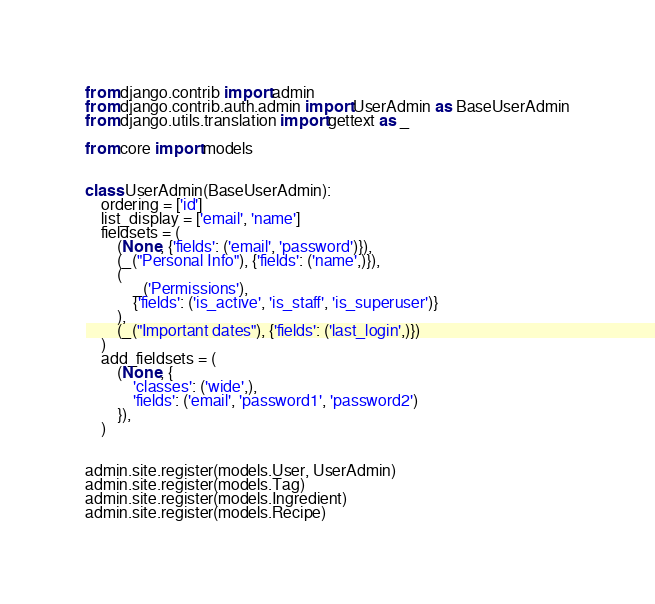Convert code to text. <code><loc_0><loc_0><loc_500><loc_500><_Python_>from django.contrib import admin
from django.contrib.auth.admin import UserAdmin as BaseUserAdmin
from django.utils.translation import gettext as _

from core import models


class UserAdmin(BaseUserAdmin):
    ordering = ['id']
    list_display = ['email', 'name']
    fieldsets = (
        (None, {'fields': ('email', 'password')}),
        (_("Personal Info"), {'fields': ('name',)}),
        (
            _('Permissions'),
            {'fields': ('is_active', 'is_staff', 'is_superuser')}
        ),
        (_("Important dates"), {'fields': ('last_login',)})
    )
    add_fieldsets = (
        (None, {
            'classes': ('wide',),
            'fields': ('email', 'password1', 'password2')
        }),
    )


admin.site.register(models.User, UserAdmin)
admin.site.register(models.Tag)
admin.site.register(models.Ingredient)
admin.site.register(models.Recipe)
</code> 